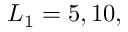Convert formula to latex. <formula><loc_0><loc_0><loc_500><loc_500>L _ { 1 } = 5 , 1 0 ,</formula> 